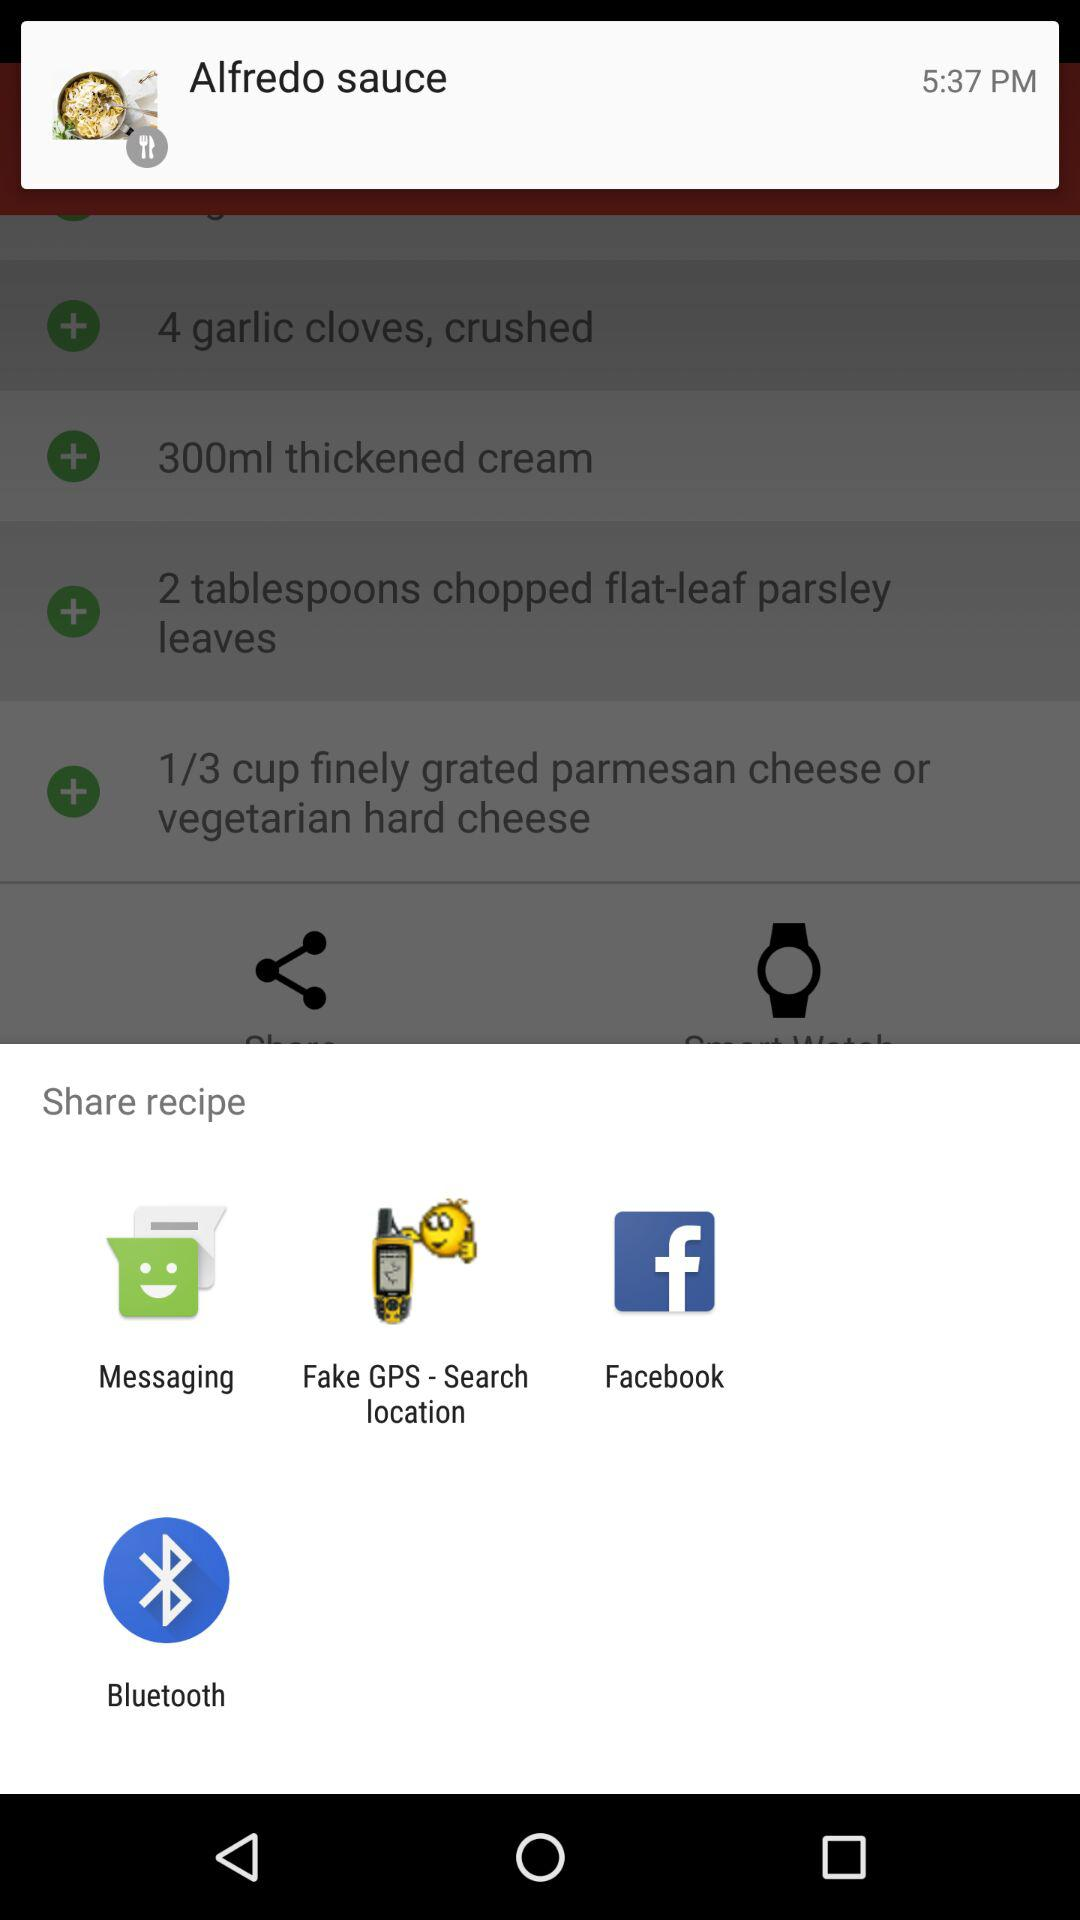What are the options for sharing the recipe? The options for sharing the recipe are "Messaging", "Fake GPS - Search location", "Facebook" and "Bluetooth". 